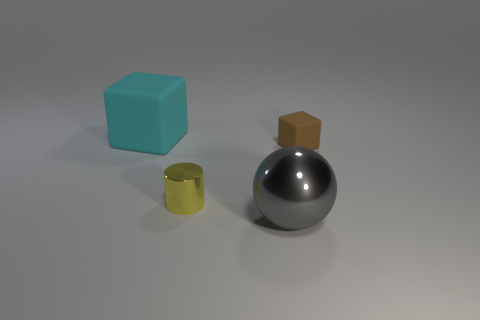Add 3 green matte spheres. How many objects exist? 7 Subtract all cylinders. How many objects are left? 3 Add 2 big cyan cubes. How many big cyan cubes exist? 3 Subtract 1 gray balls. How many objects are left? 3 Subtract all cyan rubber spheres. Subtract all large blocks. How many objects are left? 3 Add 3 big cyan rubber blocks. How many big cyan rubber blocks are left? 4 